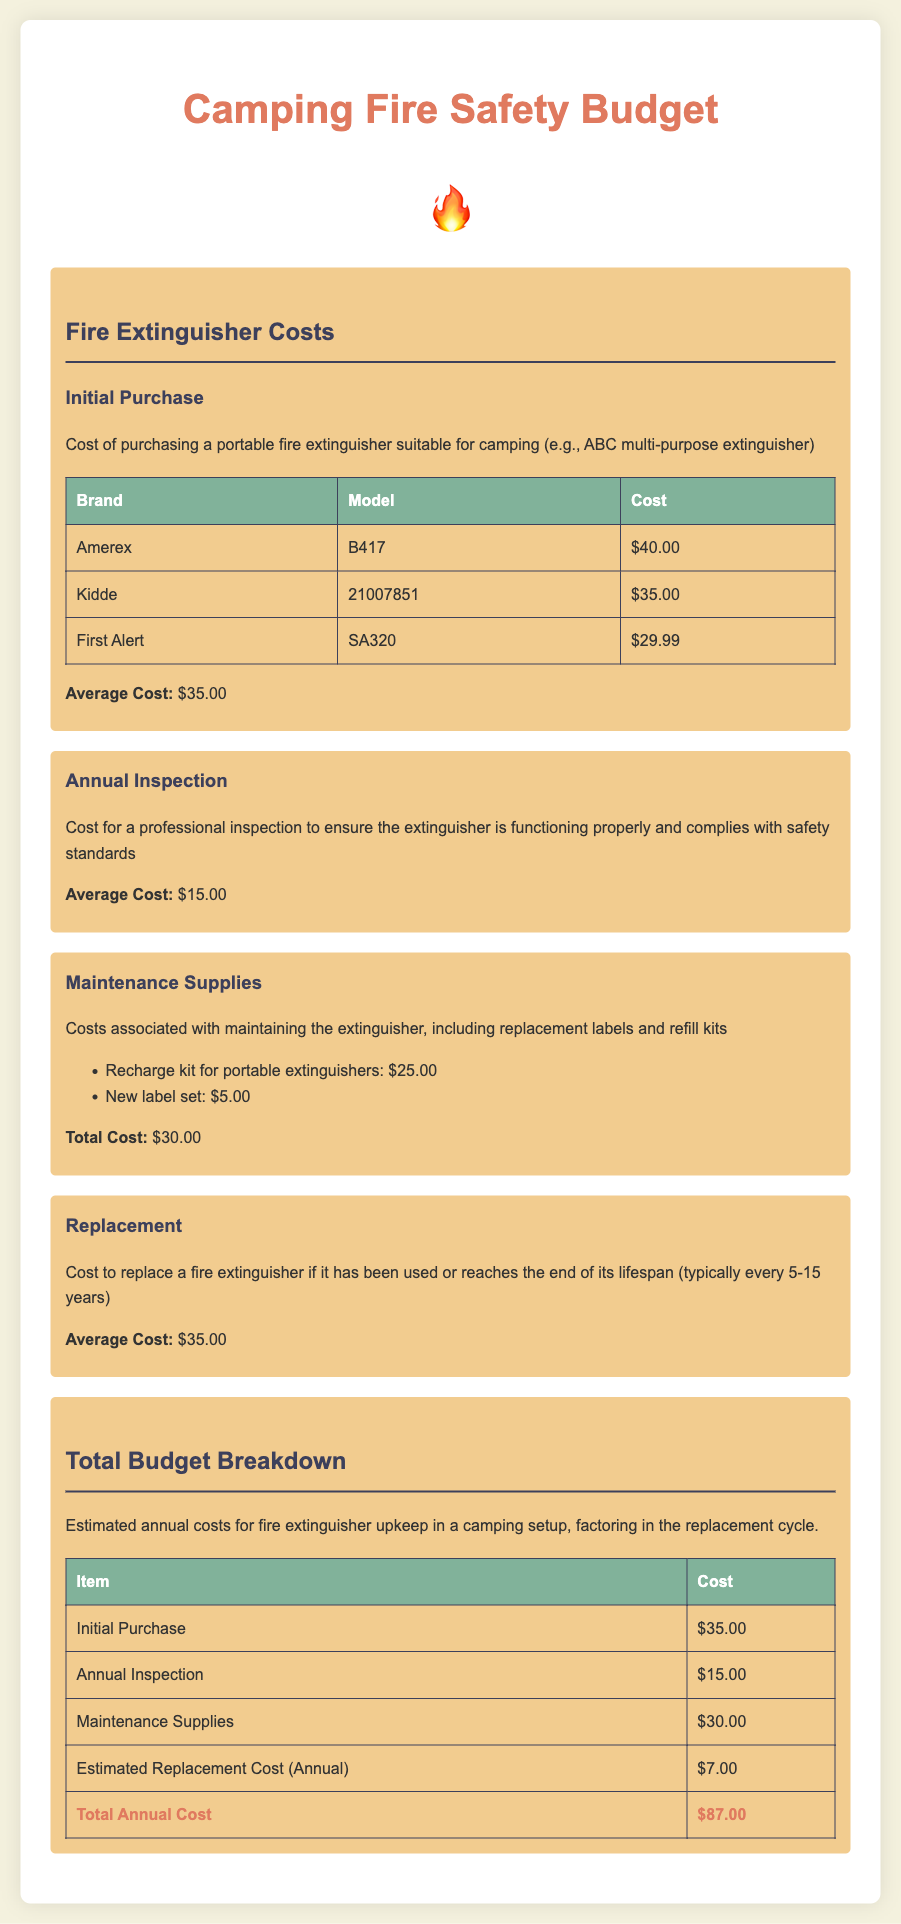what is the average cost of a fire extinguisher? The average cost of a fire extinguisher is calculated from the listed brands and models, which is $40.00, $35.00, and $29.99. The average cost is approximately $35.00.
Answer: $35.00 what is the cost for an annual inspection? The document states the cost for a professional inspection to ensure functionality and safety, which is given as $15.00.
Answer: $15.00 how much does a recharge kit cost? The document lists the cost of a recharge kit for portable extinguishers as $25.00.
Answer: $25.00 what is the total estimated annual cost for fire extinguisher upkeep? The total annual cost is explicitly detailed in the budget breakdown section and is the sum of the various expenses, which totals to $87.00.
Answer: $87.00 how often should a fire extinguisher typically be replaced? The document mentions the replacement cycle for a fire extinguisher as typically every 5-15 years.
Answer: every 5-15 years what is the cost of a new label set? The cost of a new label set is mentioned in the maintenance supplies section and is listed as $5.00.
Answer: $5.00 what brand has the highest initial purchase cost? Among the listed brands for the initial purchase, Amerex has the highest cost at $40.00.
Answer: Amerex what is the total cost for maintenance supplies? The total cost listed for maintenance supplies, including the recharge kit and new label set, amounts to $30.00.
Answer: $30.00 what is the cost of the First Alert model? The price of the First Alert model SA320 is indicated as $29.99.
Answer: $29.99 